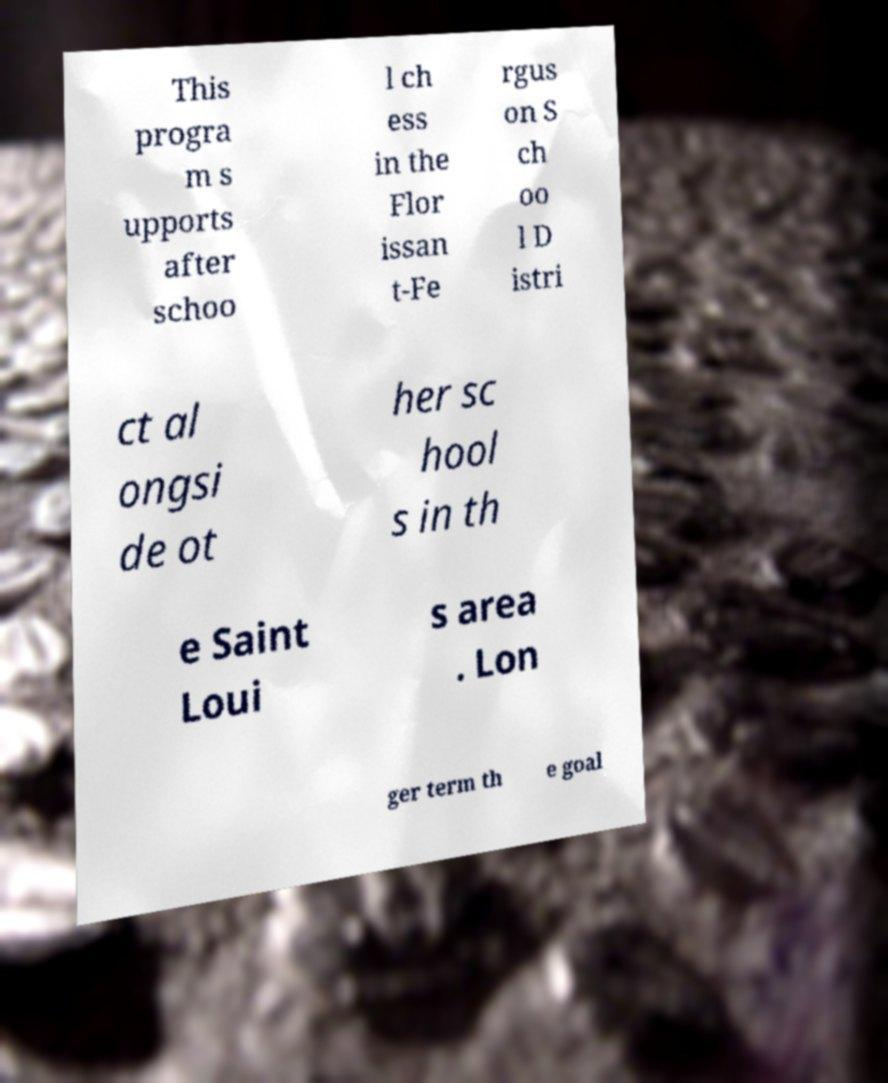Could you extract and type out the text from this image? This progra m s upports after schoo l ch ess in the Flor issan t-Fe rgus on S ch oo l D istri ct al ongsi de ot her sc hool s in th e Saint Loui s area . Lon ger term th e goal 